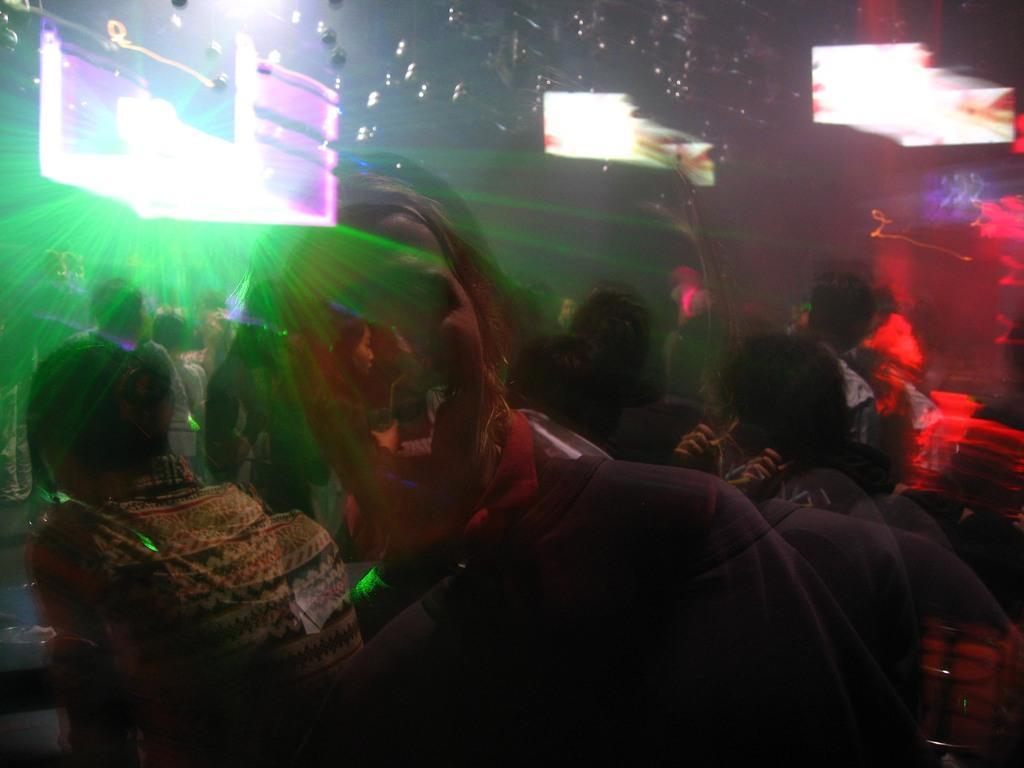Please provide a concise description of this image. In the center of the image we can see crowd. In the background we can see screens and lights. 